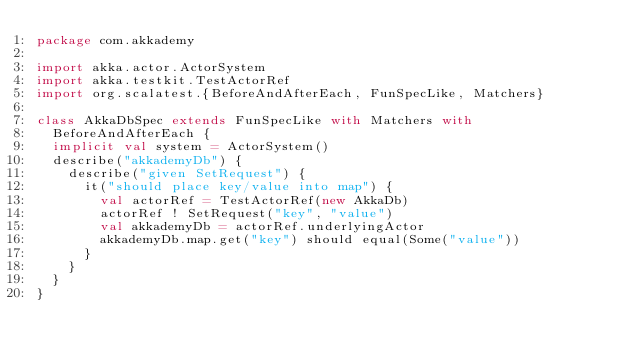Convert code to text. <code><loc_0><loc_0><loc_500><loc_500><_Scala_>package com.akkademy

import akka.actor.ActorSystem
import akka.testkit.TestActorRef
import org.scalatest.{BeforeAndAfterEach, FunSpecLike, Matchers}

class AkkaDbSpec extends FunSpecLike with Matchers with
  BeforeAndAfterEach {
  implicit val system = ActorSystem()
  describe("akkademyDb") {
    describe("given SetRequest") {
      it("should place key/value into map") {
        val actorRef = TestActorRef(new AkkaDb)
        actorRef ! SetRequest("key", "value")
        val akkademyDb = actorRef.underlyingActor
        akkademyDb.map.get("key") should equal(Some("value"))
      }
    }
  }
}</code> 